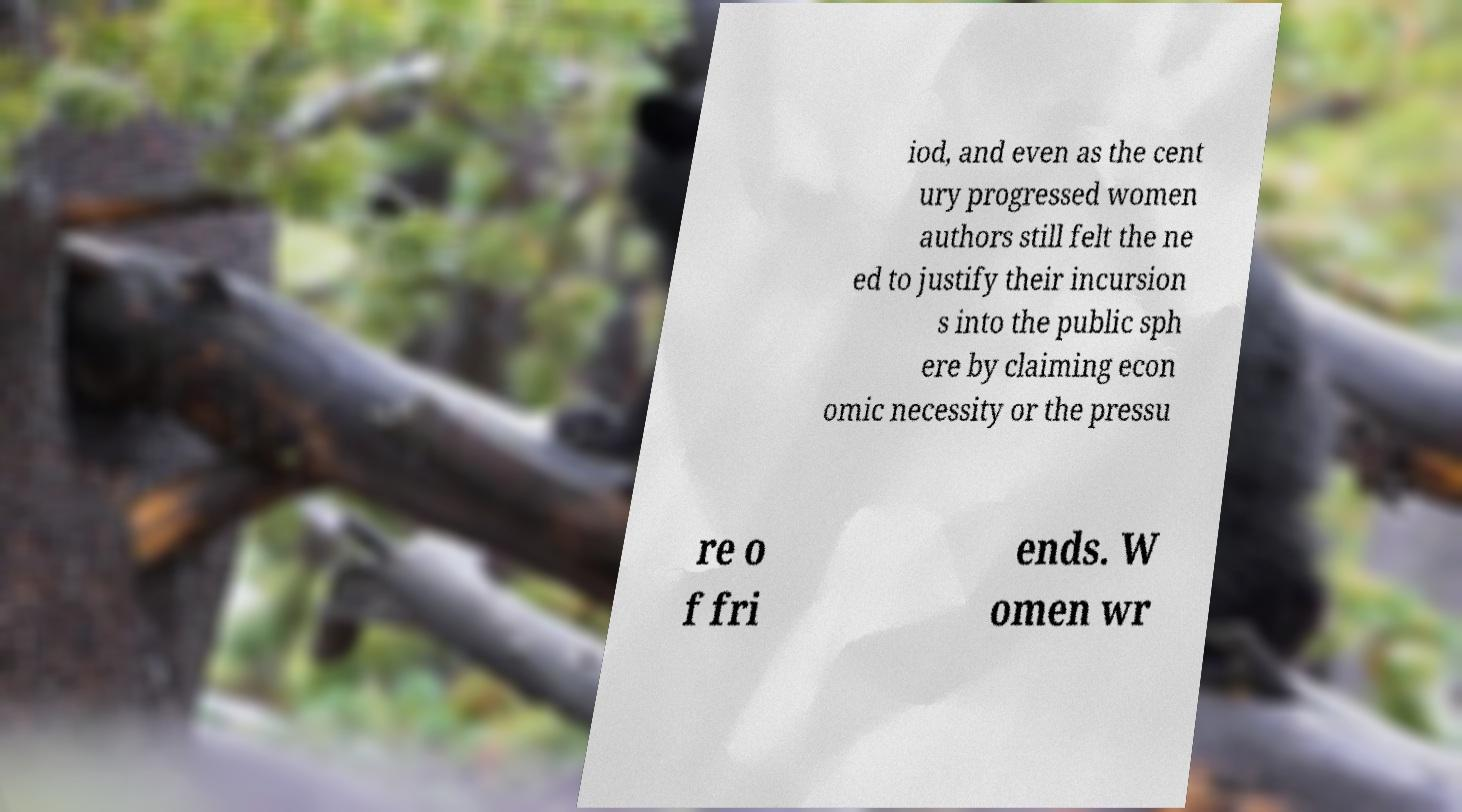For documentation purposes, I need the text within this image transcribed. Could you provide that? iod, and even as the cent ury progressed women authors still felt the ne ed to justify their incursion s into the public sph ere by claiming econ omic necessity or the pressu re o f fri ends. W omen wr 